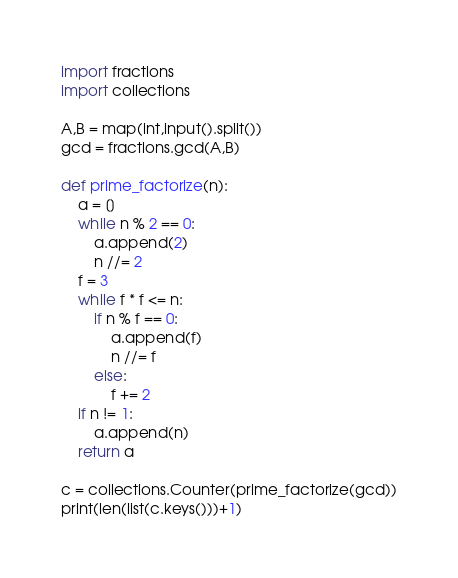<code> <loc_0><loc_0><loc_500><loc_500><_Python_>import fractions
import collections
   
A,B = map(int,input().split())
gcd = fractions.gcd(A,B)

def prime_factorize(n):
    a = []
    while n % 2 == 0:
        a.append(2)
        n //= 2
    f = 3
    while f * f <= n:
        if n % f == 0:
            a.append(f)
            n //= f
        else:
            f += 2
    if n != 1:
        a.append(n)
    return a

c = collections.Counter(prime_factorize(gcd))
print(len(list(c.keys()))+1)</code> 